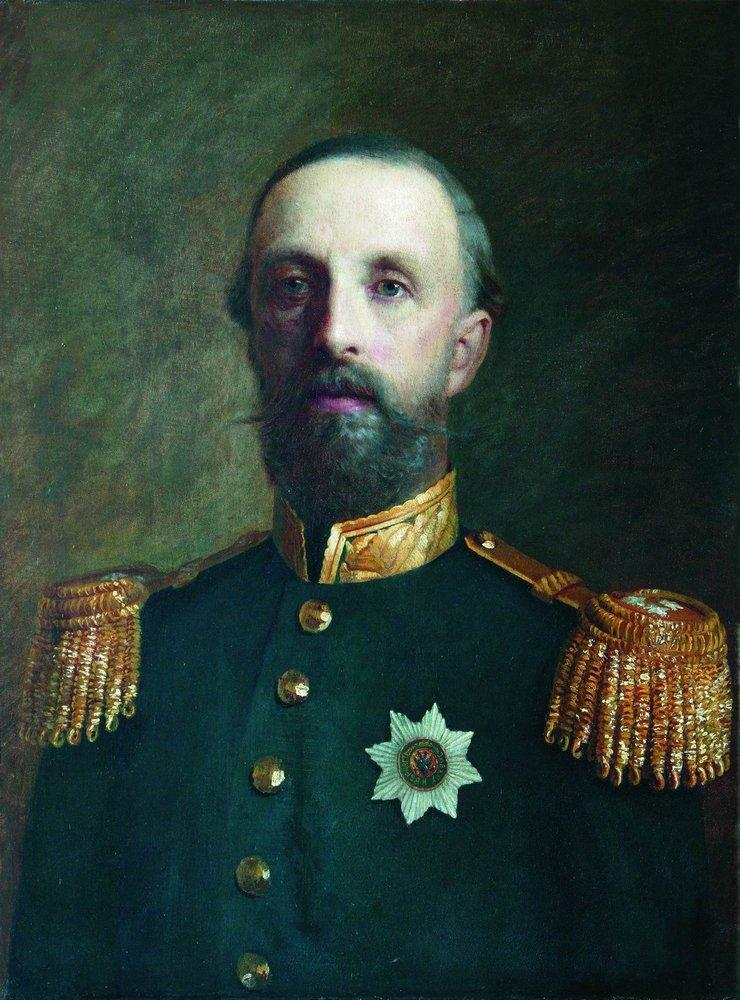Can you tell me more about the significance of the medal he is wearing? The white star medal prominently displayed on his chest is likely a high military honor, indicative of his bravery or distinguished service in his career. Such medals are awarded to military personnel who have shown exceptional merit and leadership on the battlefield or in their military duties. The exact origin of the medal can vary by country and historical period, but generally, it represents a significant recognition. 